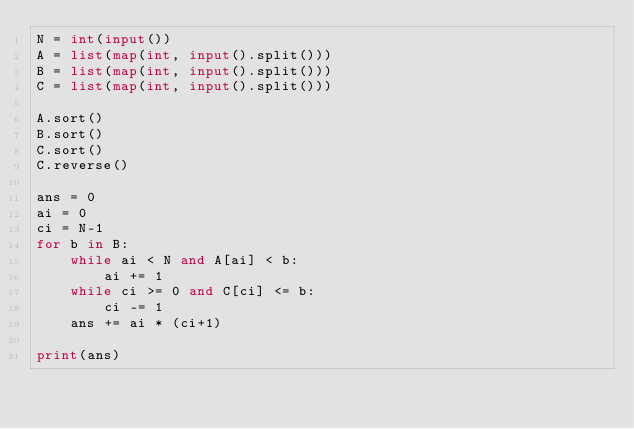Convert code to text. <code><loc_0><loc_0><loc_500><loc_500><_Python_>N = int(input())
A = list(map(int, input().split()))
B = list(map(int, input().split()))
C = list(map(int, input().split()))

A.sort()
B.sort()
C.sort()
C.reverse()

ans = 0
ai = 0
ci = N-1
for b in B:
    while ai < N and A[ai] < b:
        ai += 1
    while ci >= 0 and C[ci] <= b:
        ci -= 1
    ans += ai * (ci+1)

print(ans)</code> 